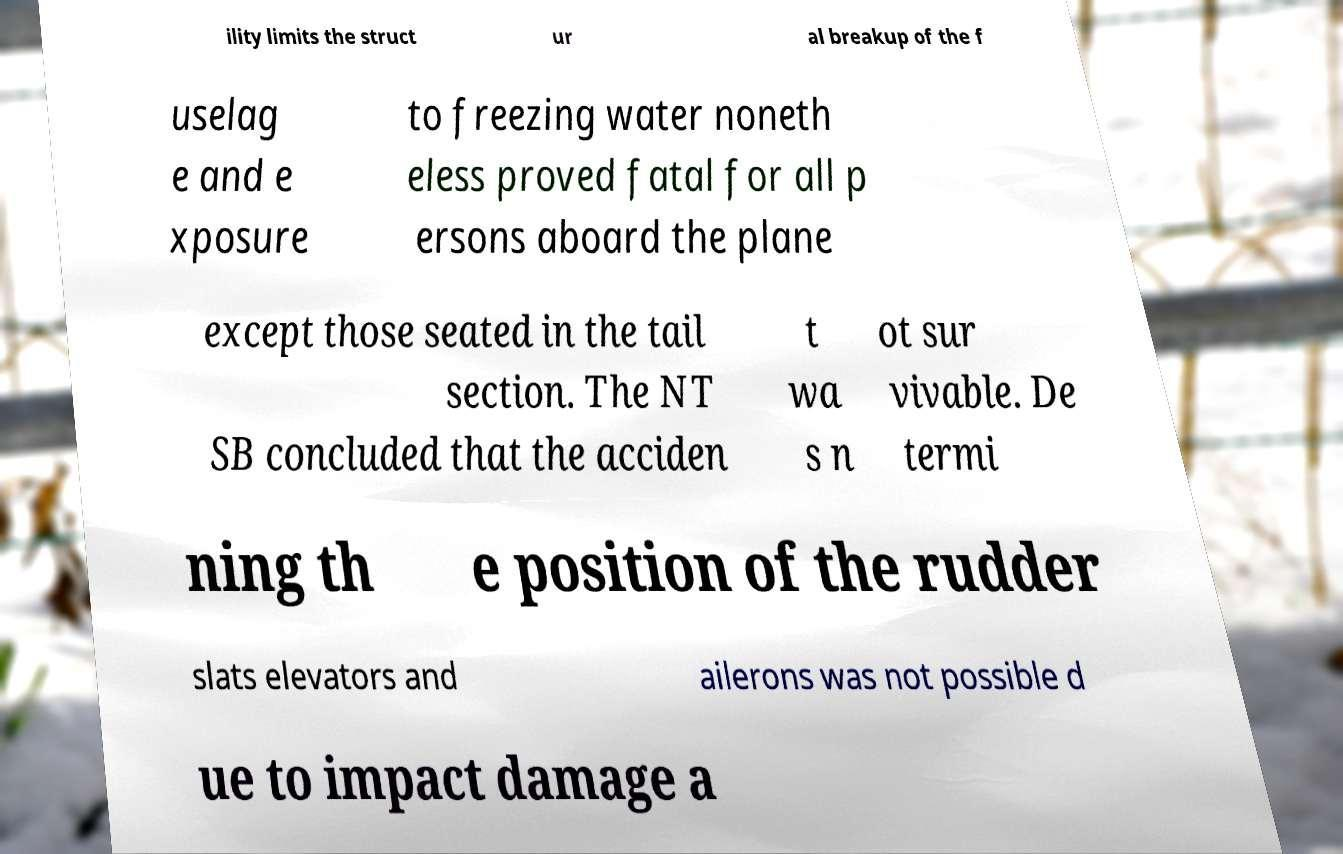What messages or text are displayed in this image? I need them in a readable, typed format. ility limits the struct ur al breakup of the f uselag e and e xposure to freezing water noneth eless proved fatal for all p ersons aboard the plane except those seated in the tail section. The NT SB concluded that the acciden t wa s n ot sur vivable. De termi ning th e position of the rudder slats elevators and ailerons was not possible d ue to impact damage a 